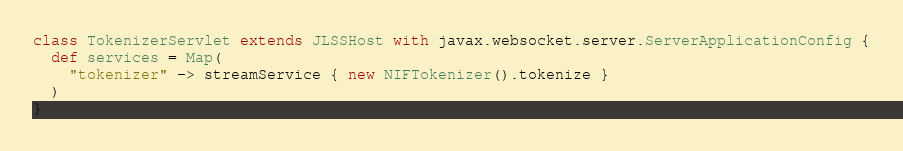<code> <loc_0><loc_0><loc_500><loc_500><_Scala_>class TokenizerServlet extends JLSSHost with javax.websocket.server.ServerApplicationConfig {
  def services = Map(
    "tokenizer" -> streamService { new NIFTokenizer().tokenize }
  )
}
</code> 